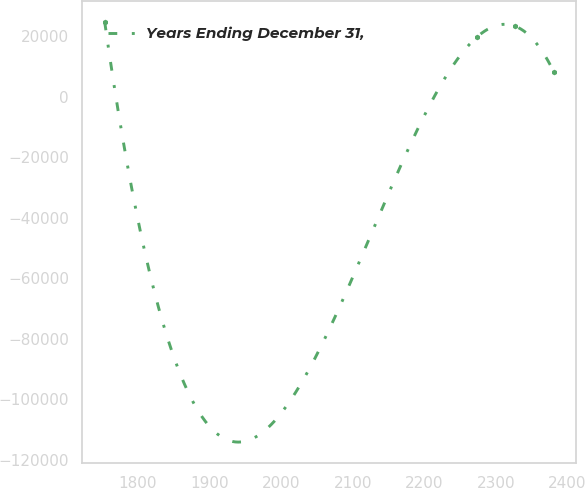Convert chart to OTSL. <chart><loc_0><loc_0><loc_500><loc_500><line_chart><ecel><fcel>Years Ending December 31,<nl><fcel>1753.43<fcel>24904.1<nl><fcel>2273.02<fcel>19669<nl><fcel>2326.97<fcel>23373.4<nl><fcel>2380.92<fcel>8321.33<nl></chart> 